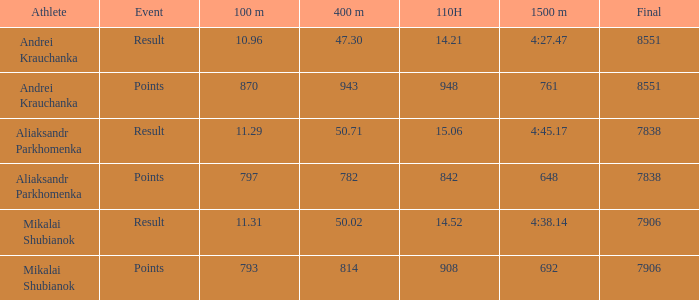What was the 100m when the 110h was below 1 None. 